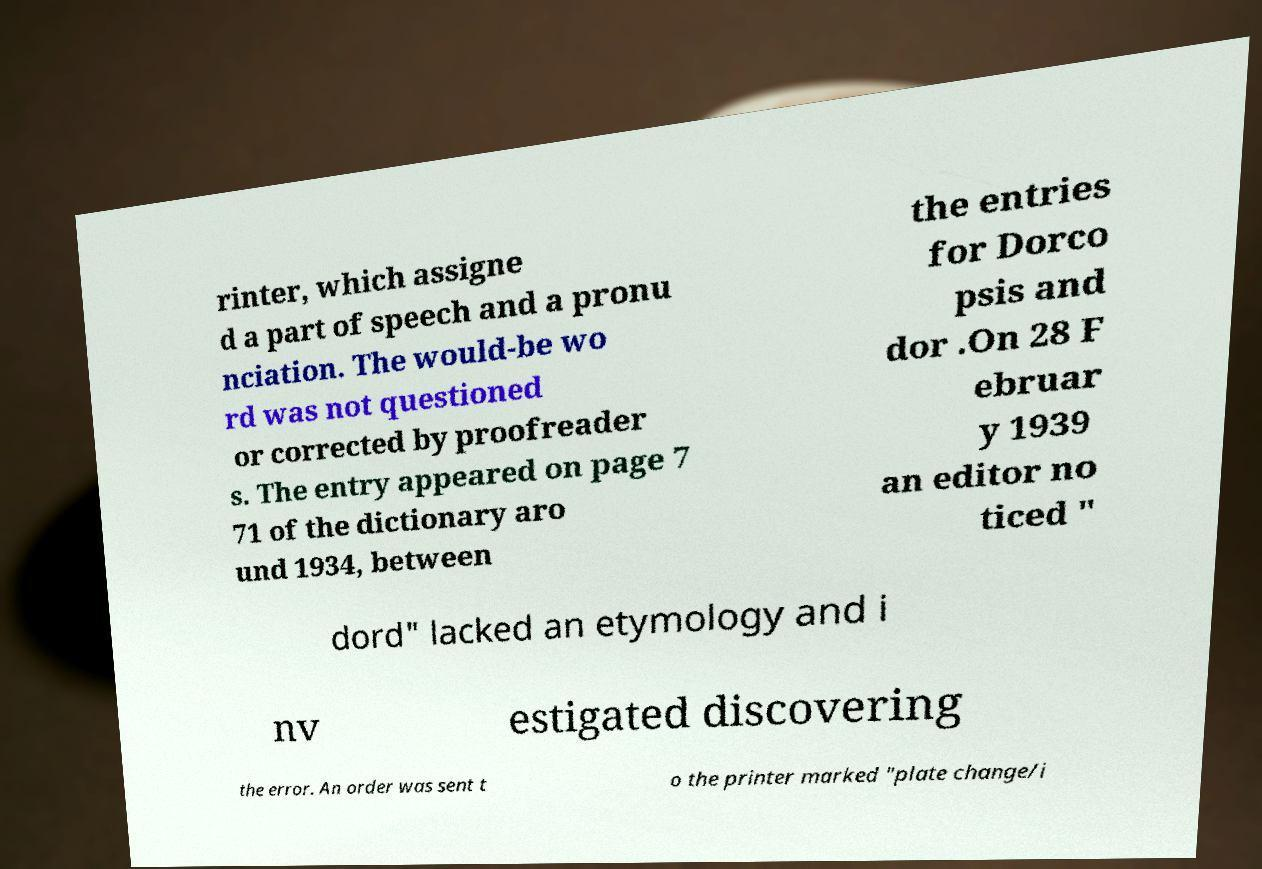I need the written content from this picture converted into text. Can you do that? rinter, which assigne d a part of speech and a pronu nciation. The would-be wo rd was not questioned or corrected by proofreader s. The entry appeared on page 7 71 of the dictionary aro und 1934, between the entries for Dorco psis and dor .On 28 F ebruar y 1939 an editor no ticed " dord" lacked an etymology and i nv estigated discovering the error. An order was sent t o the printer marked "plate change/i 